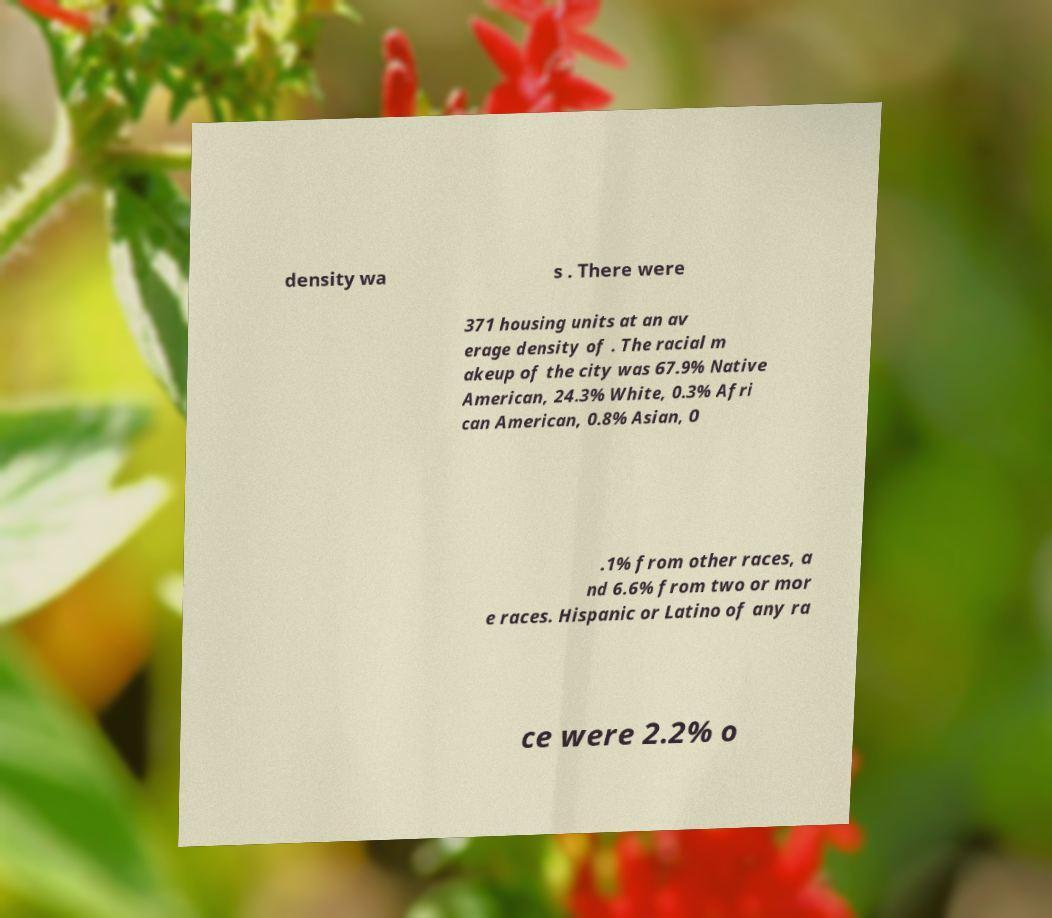Could you extract and type out the text from this image? density wa s . There were 371 housing units at an av erage density of . The racial m akeup of the city was 67.9% Native American, 24.3% White, 0.3% Afri can American, 0.8% Asian, 0 .1% from other races, a nd 6.6% from two or mor e races. Hispanic or Latino of any ra ce were 2.2% o 